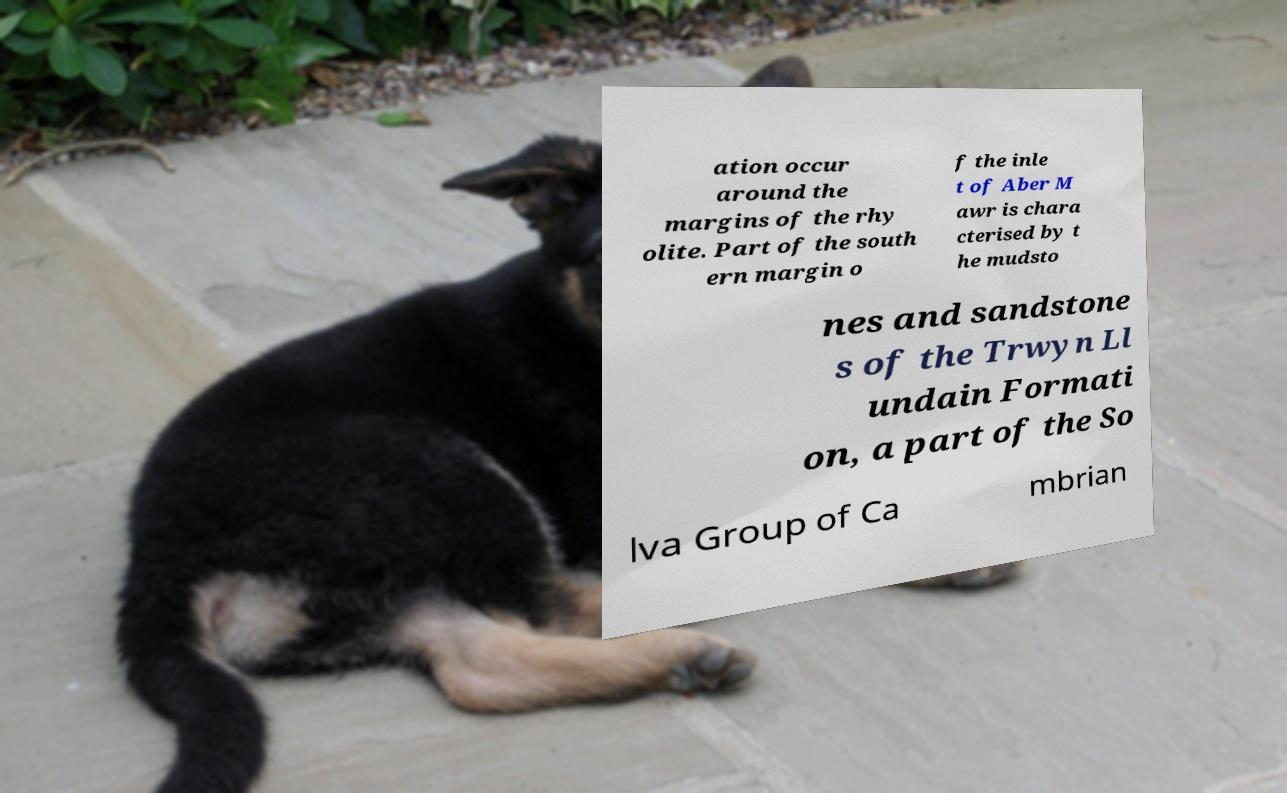For documentation purposes, I need the text within this image transcribed. Could you provide that? ation occur around the margins of the rhy olite. Part of the south ern margin o f the inle t of Aber M awr is chara cterised by t he mudsto nes and sandstone s of the Trwyn Ll undain Formati on, a part of the So lva Group of Ca mbrian 